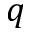<formula> <loc_0><loc_0><loc_500><loc_500>q</formula> 